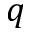<formula> <loc_0><loc_0><loc_500><loc_500>q</formula> 